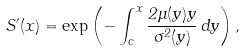<formula> <loc_0><loc_0><loc_500><loc_500>S ^ { \prime } ( x ) = \exp \left ( - \int _ { c } ^ { x } \frac { 2 \mu ( y ) y } { \sigma ^ { 2 } ( y ) } \, d y \right ) ,</formula> 